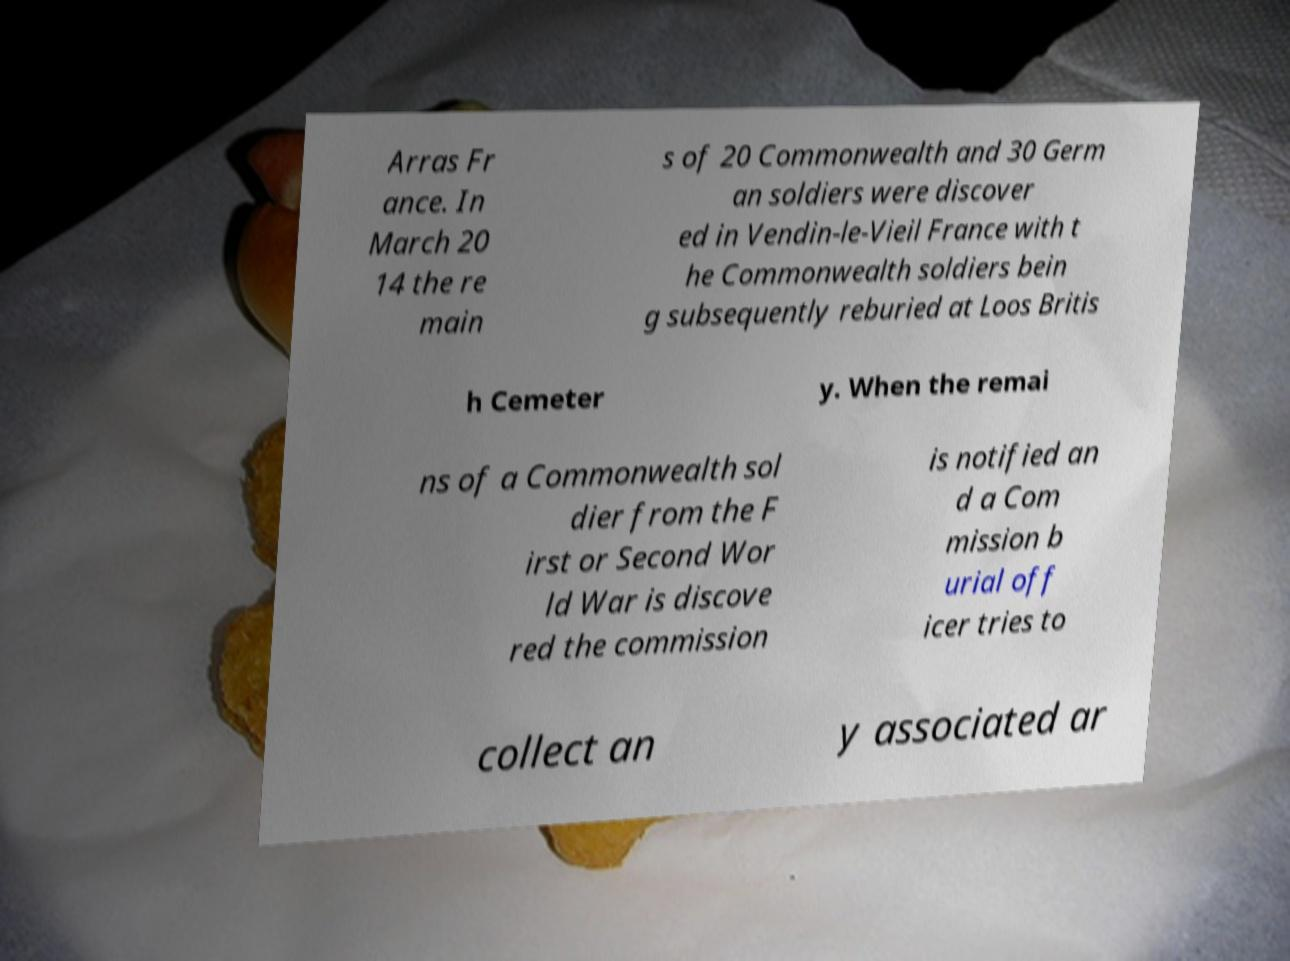Please read and relay the text visible in this image. What does it say? Arras Fr ance. In March 20 14 the re main s of 20 Commonwealth and 30 Germ an soldiers were discover ed in Vendin-le-Vieil France with t he Commonwealth soldiers bein g subsequently reburied at Loos Britis h Cemeter y. When the remai ns of a Commonwealth sol dier from the F irst or Second Wor ld War is discove red the commission is notified an d a Com mission b urial off icer tries to collect an y associated ar 